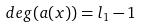Convert formula to latex. <formula><loc_0><loc_0><loc_500><loc_500>d e g ( a ( x ) ) = l _ { 1 } - 1</formula> 